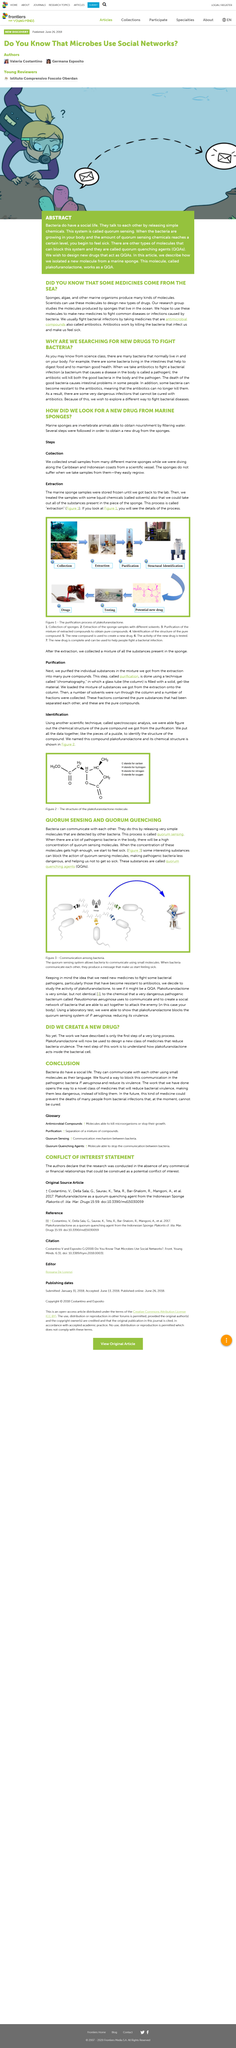Highlight a few significant elements in this photo. The person on the right in the image represents sickness, and sickness is a result of what is shown in the image. After purification, the next step in the 7-step process is structural identification, where the structure of the compound is identified. Bacteria communicate through a system called quorum sensing, which enables them to coordinate their behavior in response to changes in population density. Small samples were collected from marine sponges along the coasts using a scientific vessel during diving expeditions for the purpose of study. The quorum sensing system of P. aeruginosa was successfully blocked using plakofuranolactone. 